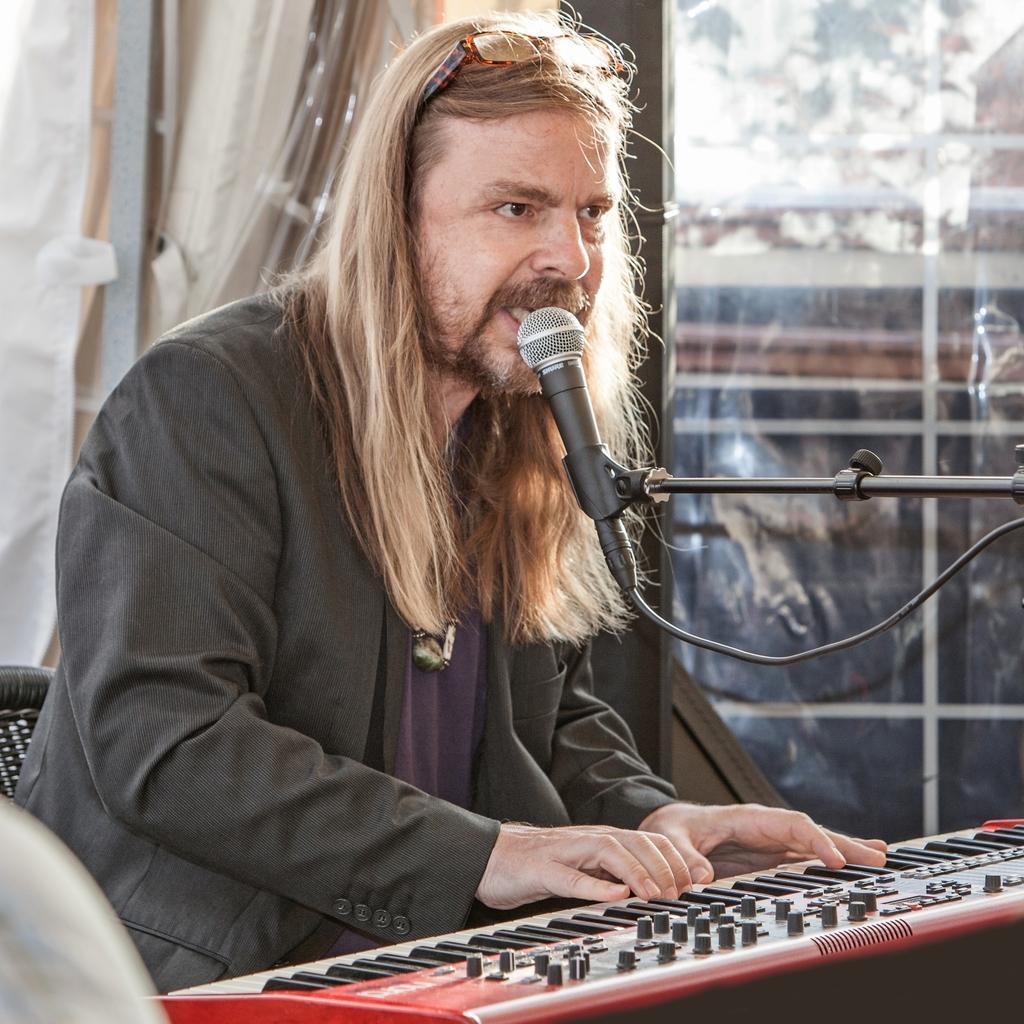Could you give a brief overview of what you see in this image? In the picture we can see a man sitting on the chair and playing a keyboard and singing a song in the microphone which is to the stand and he is with a black blazer and long hair which are cream in color and in the background we can see a glass wall. 